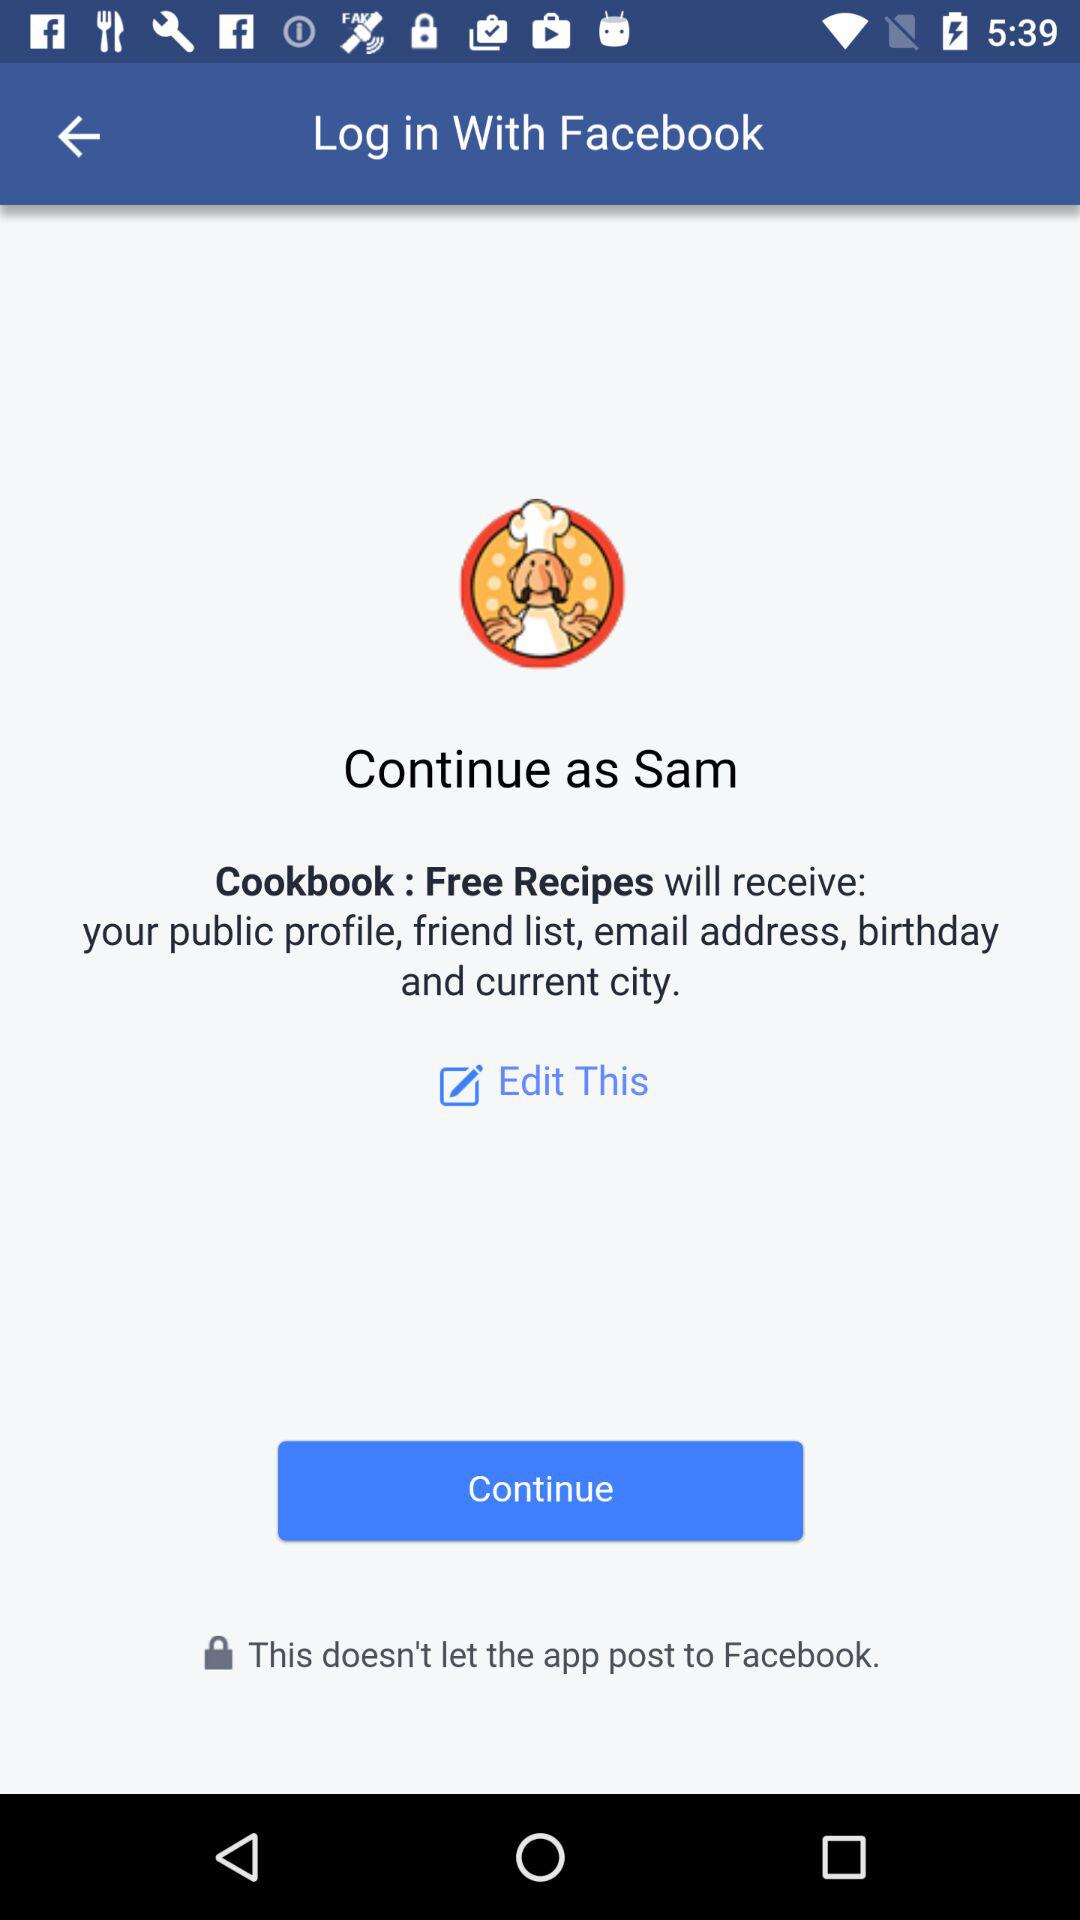What is the name of the user? The user name is Sam. 